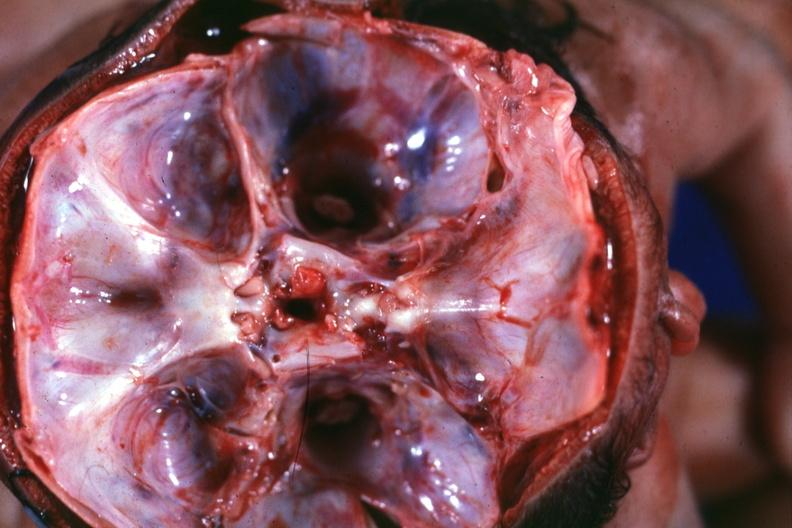does this image show opened skull looking into foramina magna single fused calvarium twins with separate brainstems?
Answer the question using a single word or phrase. Yes 